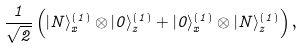Convert formula to latex. <formula><loc_0><loc_0><loc_500><loc_500>\frac { 1 } { \sqrt { 2 } } \left ( | N \rangle _ { x } ^ { ( 1 ) } \otimes | 0 \rangle _ { z } ^ { ( 1 ) } + | 0 \rangle _ { x } ^ { ( 1 ) } \otimes | N \rangle _ { z } ^ { ( 1 ) } \right ) ,</formula> 